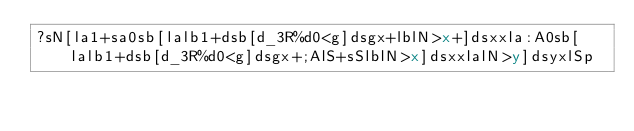<code> <loc_0><loc_0><loc_500><loc_500><_dc_>?sN[la1+sa0sb[lalb1+dsb[d_3R%d0<g]dsgx+lblN>x+]dsxxla:A0sb[lalb1+dsb[d_3R%d0<g]dsgx+;AlS+sSlblN>x]dsxxlalN>y]dsyxlSp</code> 